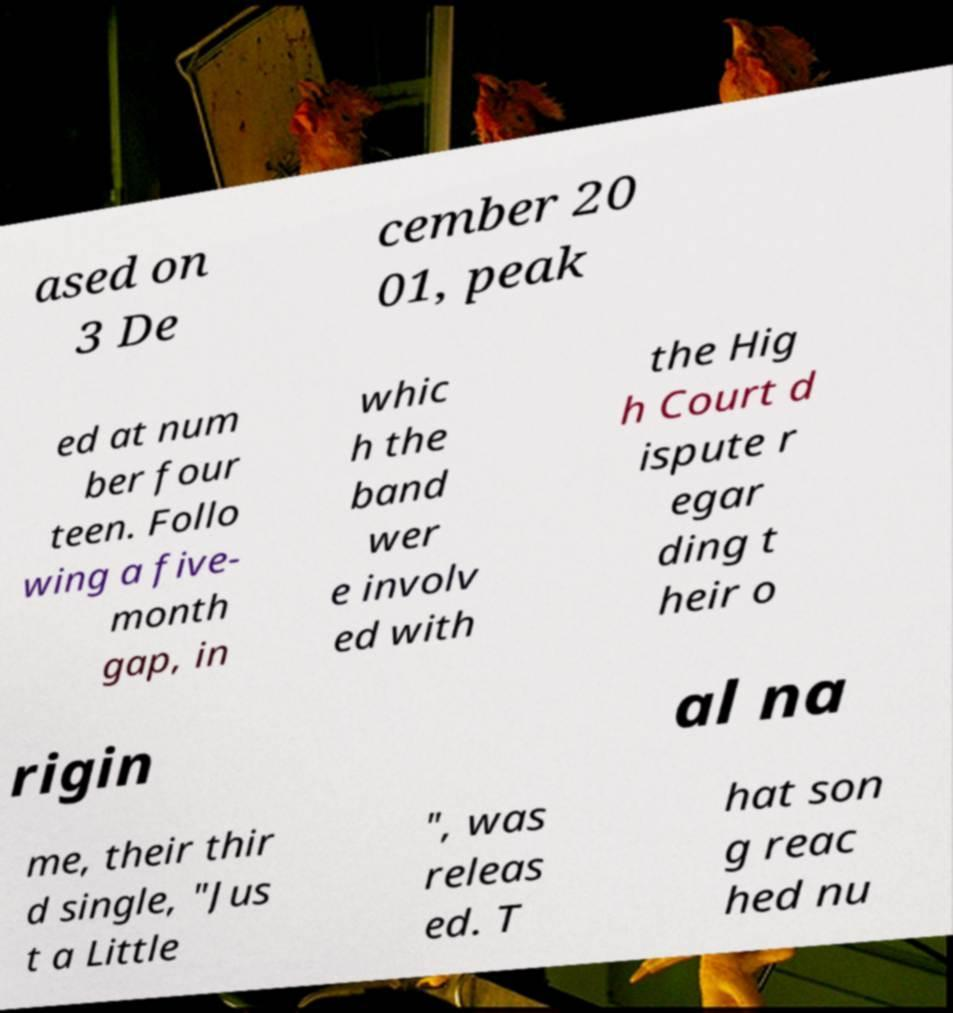There's text embedded in this image that I need extracted. Can you transcribe it verbatim? ased on 3 De cember 20 01, peak ed at num ber four teen. Follo wing a five- month gap, in whic h the band wer e involv ed with the Hig h Court d ispute r egar ding t heir o rigin al na me, their thir d single, "Jus t a Little ", was releas ed. T hat son g reac hed nu 